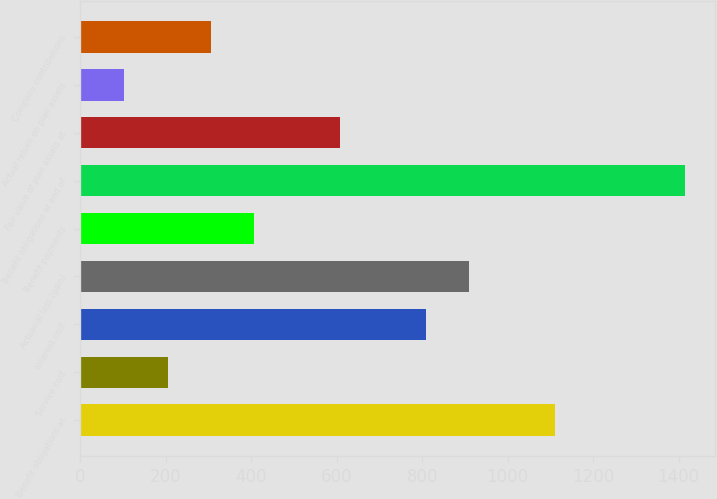<chart> <loc_0><loc_0><loc_500><loc_500><bar_chart><fcel>Benefit obligations at<fcel>Service cost<fcel>Interest cost<fcel>Actuarial loss (gain)<fcel>Benefit payments<fcel>Benefit obligations at end of<fcel>Fair value of plan assets at<fcel>Actual return on plan assets<fcel>Company contributions<nl><fcel>1111.8<fcel>204.6<fcel>809.4<fcel>910.2<fcel>406.2<fcel>1414.2<fcel>607.8<fcel>103.8<fcel>305.4<nl></chart> 